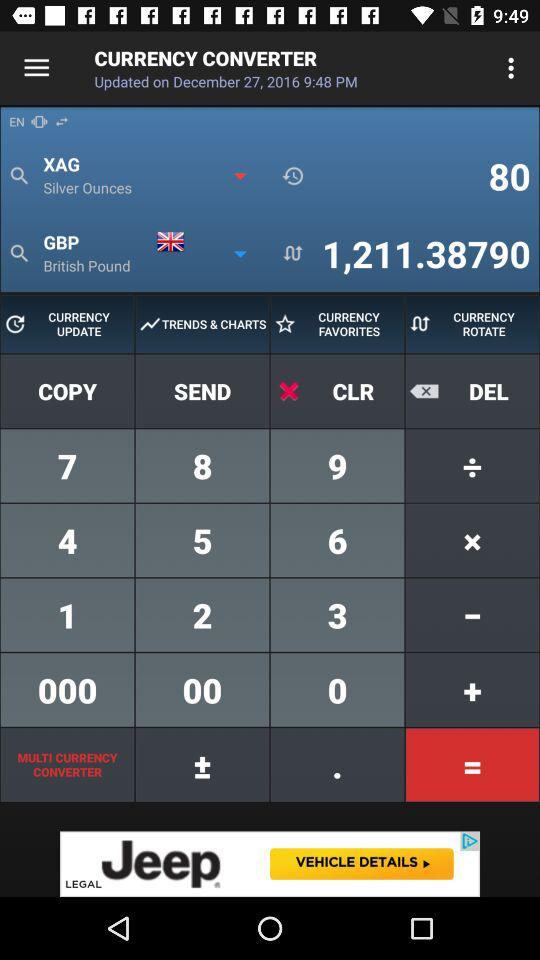XAG is converted to which currency? XAG is converted to GBP. 